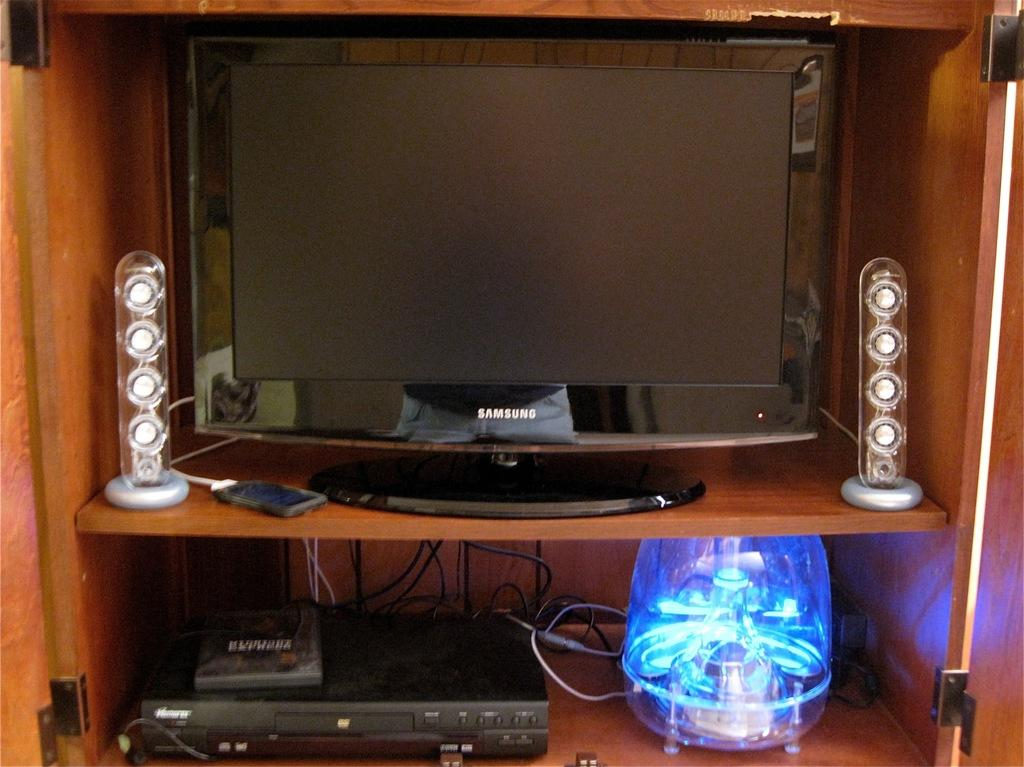Provide a one-sentence caption for the provided image. A Samsung TV on the shelf of a wooden entertainment center. 